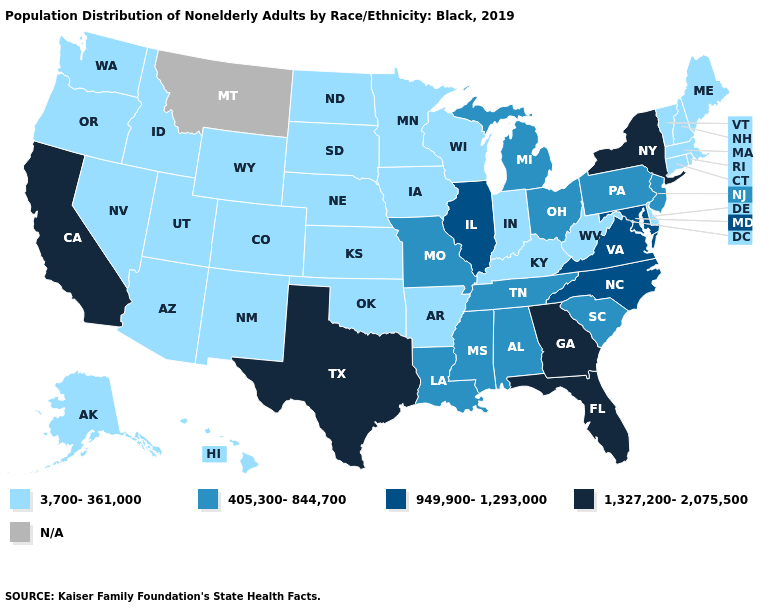Which states hav the highest value in the MidWest?
Keep it brief. Illinois. Does South Dakota have the highest value in the MidWest?
Give a very brief answer. No. Name the states that have a value in the range N/A?
Be succinct. Montana. Does Utah have the highest value in the West?
Answer briefly. No. What is the value of Montana?
Concise answer only. N/A. What is the lowest value in the Northeast?
Keep it brief. 3,700-361,000. What is the lowest value in states that border California?
Concise answer only. 3,700-361,000. Name the states that have a value in the range N/A?
Concise answer only. Montana. Does Texas have the highest value in the South?
Give a very brief answer. Yes. What is the highest value in the USA?
Be succinct. 1,327,200-2,075,500. What is the highest value in states that border Wyoming?
Short answer required. 3,700-361,000. What is the lowest value in the USA?
Be succinct. 3,700-361,000. What is the value of South Dakota?
Quick response, please. 3,700-361,000. 